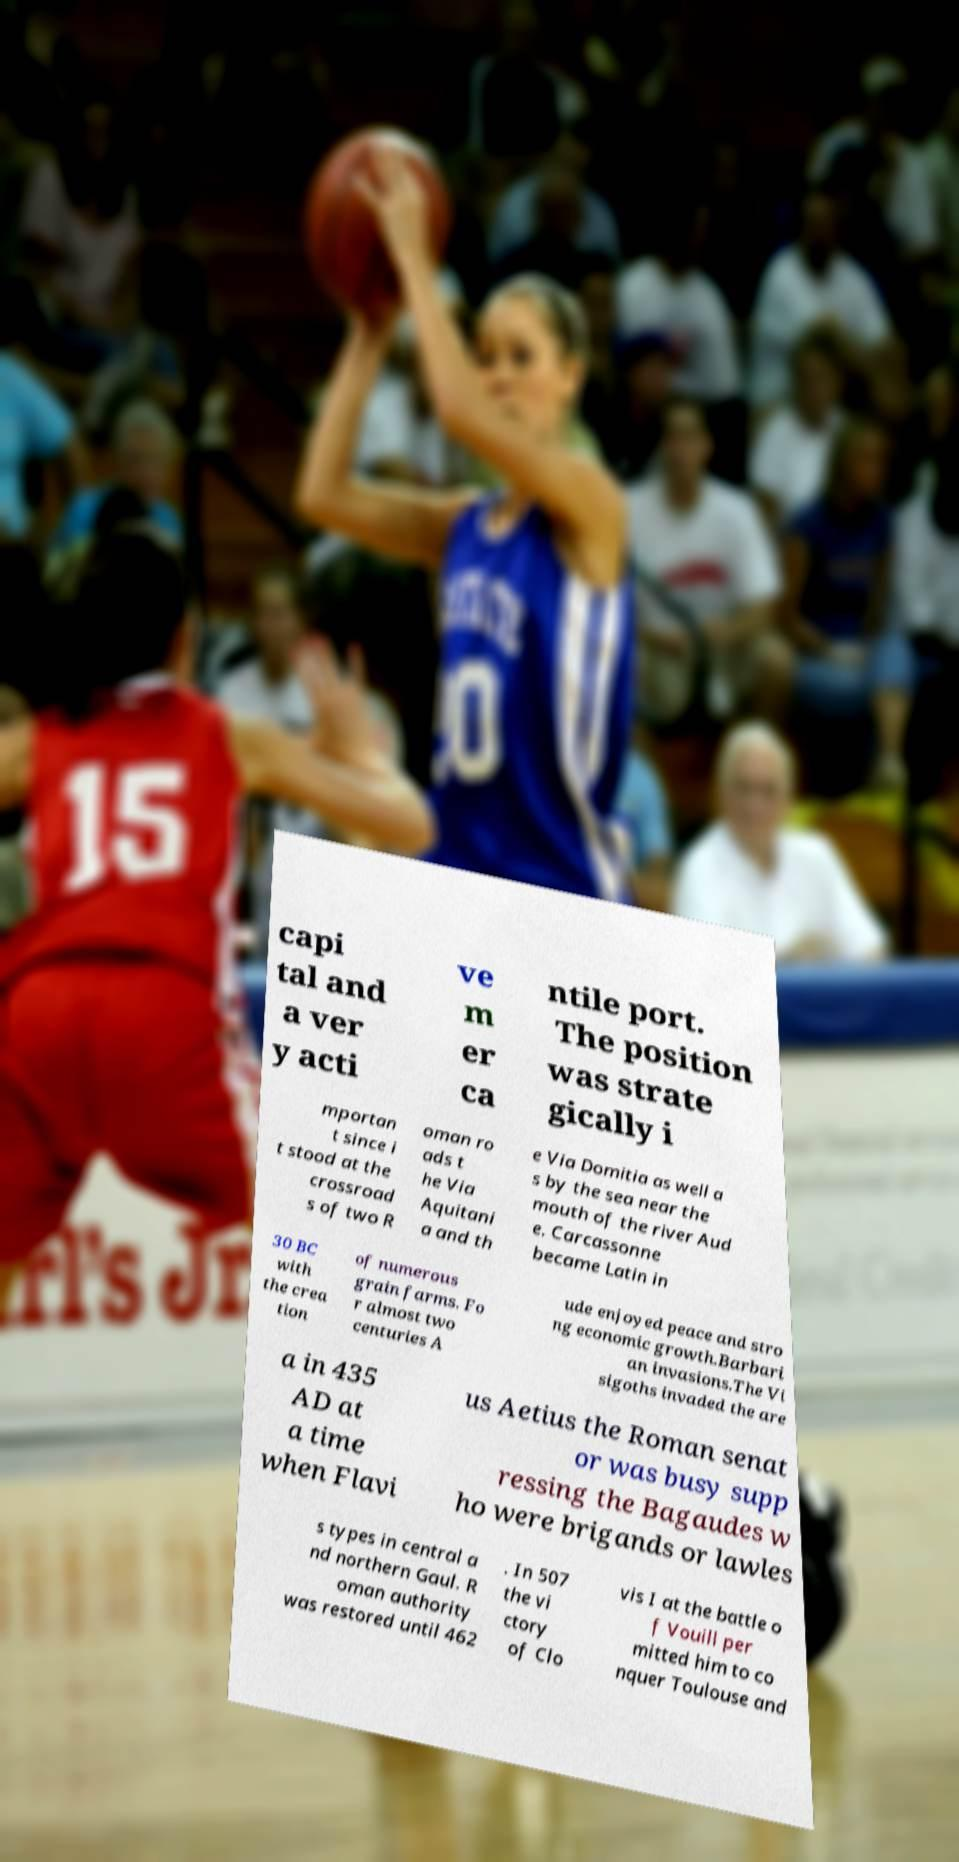Please identify and transcribe the text found in this image. capi tal and a ver y acti ve m er ca ntile port. The position was strate gically i mportan t since i t stood at the crossroad s of two R oman ro ads t he Via Aquitani a and th e Via Domitia as well a s by the sea near the mouth of the river Aud e. Carcassonne became Latin in 30 BC with the crea tion of numerous grain farms. Fo r almost two centuries A ude enjoyed peace and stro ng economic growth.Barbari an invasions.The Vi sigoths invaded the are a in 435 AD at a time when Flavi us Aetius the Roman senat or was busy supp ressing the Bagaudes w ho were brigands or lawles s types in central a nd northern Gaul. R oman authority was restored until 462 . In 507 the vi ctory of Clo vis I at the battle o f Vouill per mitted him to co nquer Toulouse and 